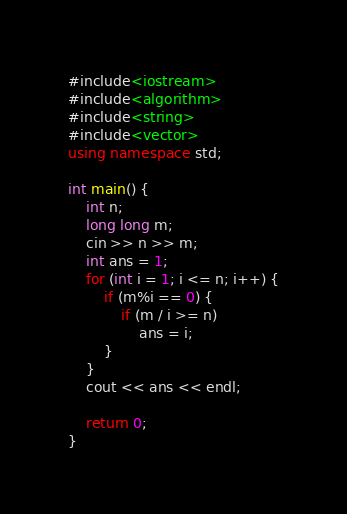<code> <loc_0><loc_0><loc_500><loc_500><_C++_>#include<iostream>
#include<algorithm>
#include<string>
#include<vector>
using namespace std;

int main() {
	int n;
	long long m;
	cin >> n >> m;
	int ans = 1;
	for (int i = 1; i <= n; i++) {
		if (m%i == 0) {
			if (m / i >= n)
				ans = i;
		}
	}
	cout << ans << endl;

	return 0;
}</code> 